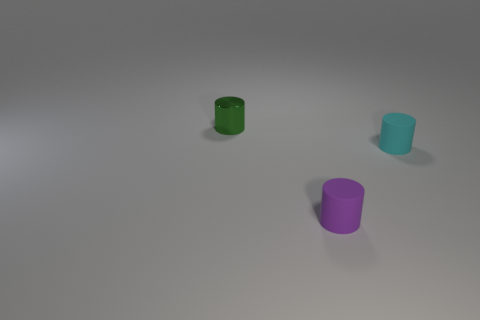Add 3 small green cylinders. How many objects exist? 6 Subtract all tiny metal cylinders. How many cylinders are left? 2 Subtract all small metal cylinders. Subtract all metallic objects. How many objects are left? 1 Add 2 tiny green objects. How many tiny green objects are left? 3 Add 3 tiny green metallic things. How many tiny green metallic things exist? 4 Subtract 0 blue balls. How many objects are left? 3 Subtract all yellow cylinders. Subtract all purple spheres. How many cylinders are left? 3 